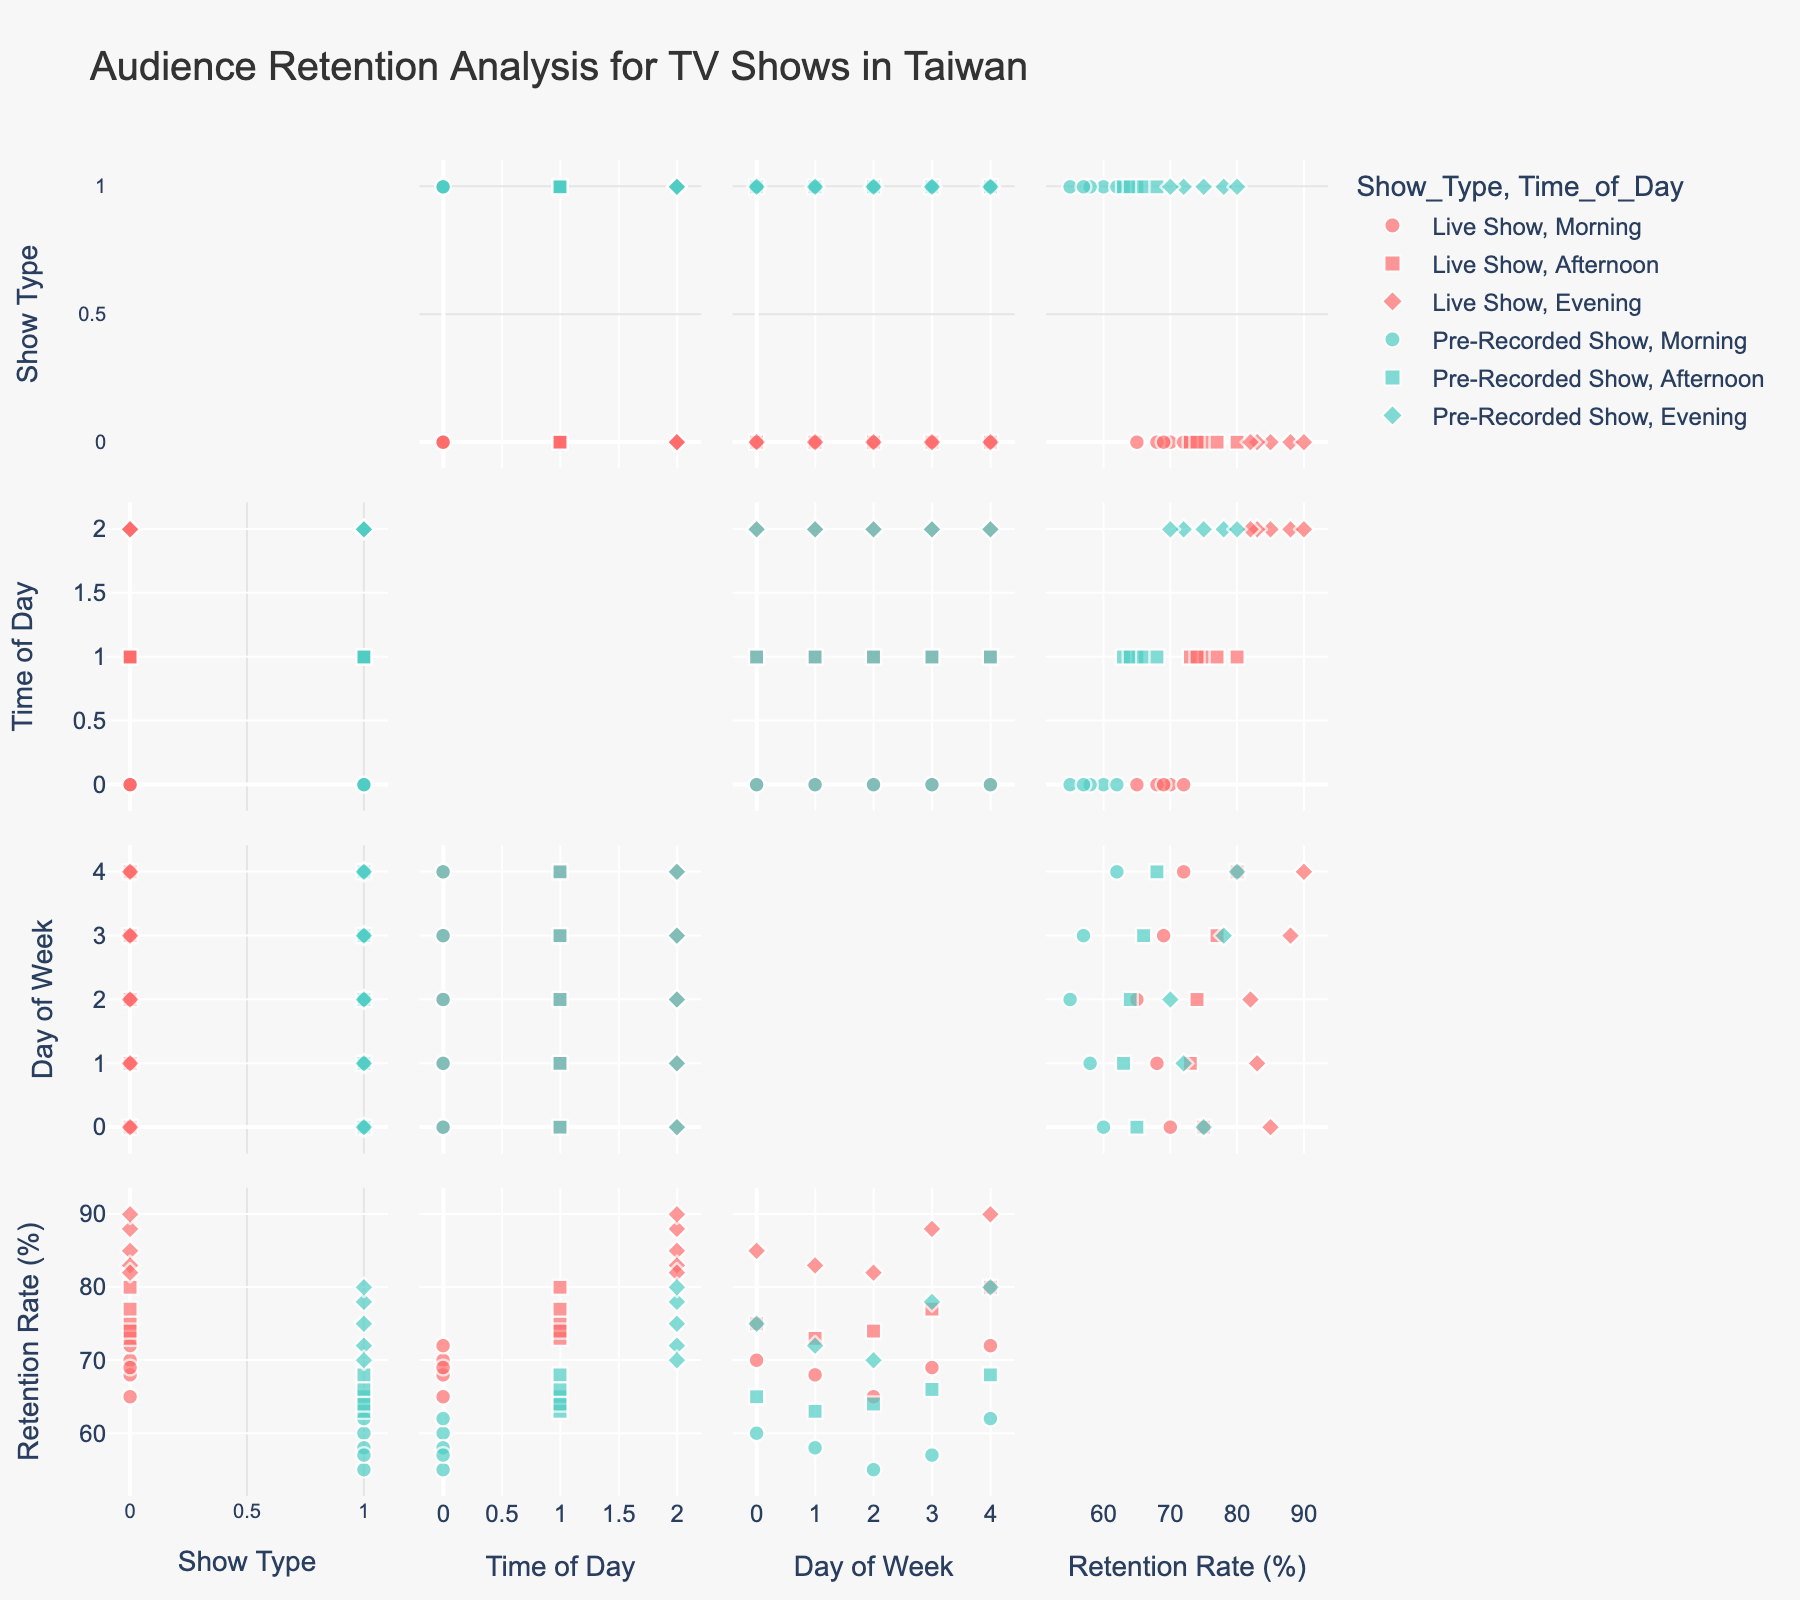What is the title of the figure? The title is located at the top of the figure. It reads "Audience Retention Analysis for TV Shows in Taiwan".
Answer: Audience Retention Analysis for TV Shows in Taiwan What are the two show types displayed in the figure? The show types are distinguished by color in the plot. There are two colors used, which are labeled in the legend as "Live Show" and "Pre-Recorded Show".
Answer: Live Show and Pre-Recorded Show Which time of day has the highest audience retention for 'Live Show'? The 'Live Show' data points colored in red display various shapes for different times of the day. The highest audience retention rate for 'Live Show' is represented by a diamond shape in the evening time slot.
Answer: Evening Which day of the week in the 'Afternoon' time slot has the highest retention rate for 'Pre-Recorded Shows'? For 'Pre-Recorded Shows', look at the green square markers representing the 'Afternoon'. The highest retention rate can be found on Friday.
Answer: Friday What is the overall trend of 'Live Show' retention rates across different times of the day? By observing the red data points for 'Live Show' across morning, afternoon, and evening time slots, we can see that the retention rate generally increases as the day progresses, being highest in the evening.
Answer: Rises towards evening How does the audience retention rate vary between 'Live Show' and 'Pre-Recorded Show' during mornings? Compare the retention rates between the red circles (Live Show) and green circles (Pre-Recorded Show) in the morning. 'Live Show' consistently has higher retention rates compared to 'Pre-Recorded Shows' in the morning.
Answer: Live Show has higher retention rates What is the range of retention rates for 'Pre-Recorded Shows' in the 'Evening'? Examine the green diamond markers which indicate 'Pre-Recorded Shows' in the evening. The retention rates for these points fall between 70 and 80%.
Answer: 70% to 80% In what time slot and day of the week does 'Live Show' achieve a retention rate of 80%? Look for a red square indicating 'Live Show' in the Afternoon time slot. The retention rate is exactly 80%, which occurs on Friday.
Answer: Friday Afternoon Which show type has more variation in audience retention rates throughout the week in the morning? Compare the spread of the retention rates in the 'Morning' between the red circles (Live Show) and green circles (Pre-Recorded Show). 'Pre-Recorded Show' has more variation, with rates between 55% to 62%.
Answer: Pre-Recorded Show 